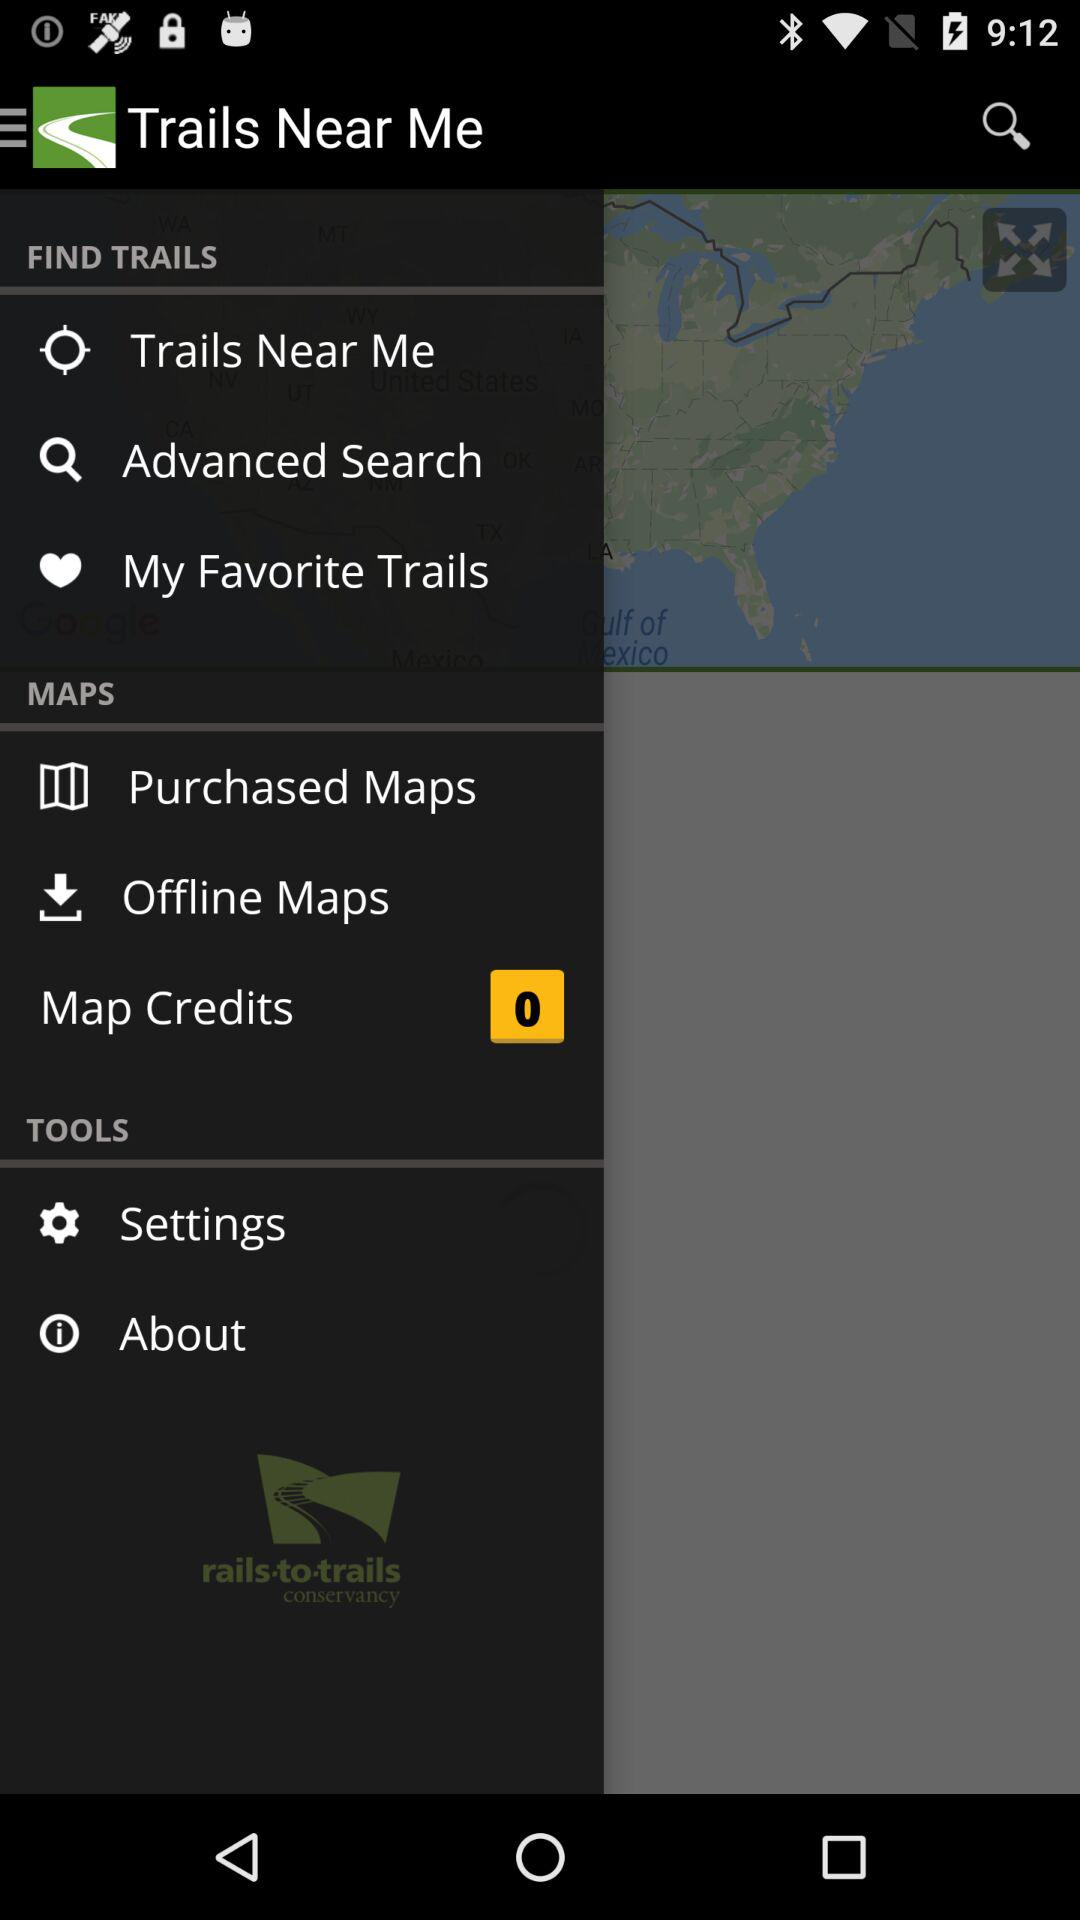What is the number shown in the map credits? The number is 0. 